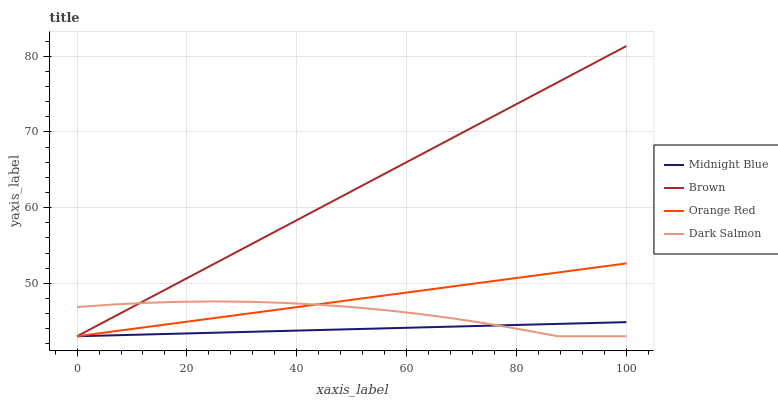Does Midnight Blue have the minimum area under the curve?
Answer yes or no. Yes. Does Brown have the maximum area under the curve?
Answer yes or no. Yes. Does Dark Salmon have the minimum area under the curve?
Answer yes or no. No. Does Dark Salmon have the maximum area under the curve?
Answer yes or no. No. Is Orange Red the smoothest?
Answer yes or no. Yes. Is Dark Salmon the roughest?
Answer yes or no. Yes. Is Midnight Blue the smoothest?
Answer yes or no. No. Is Midnight Blue the roughest?
Answer yes or no. No. Does Brown have the lowest value?
Answer yes or no. Yes. Does Brown have the highest value?
Answer yes or no. Yes. Does Dark Salmon have the highest value?
Answer yes or no. No. Does Brown intersect Orange Red?
Answer yes or no. Yes. Is Brown less than Orange Red?
Answer yes or no. No. Is Brown greater than Orange Red?
Answer yes or no. No. 